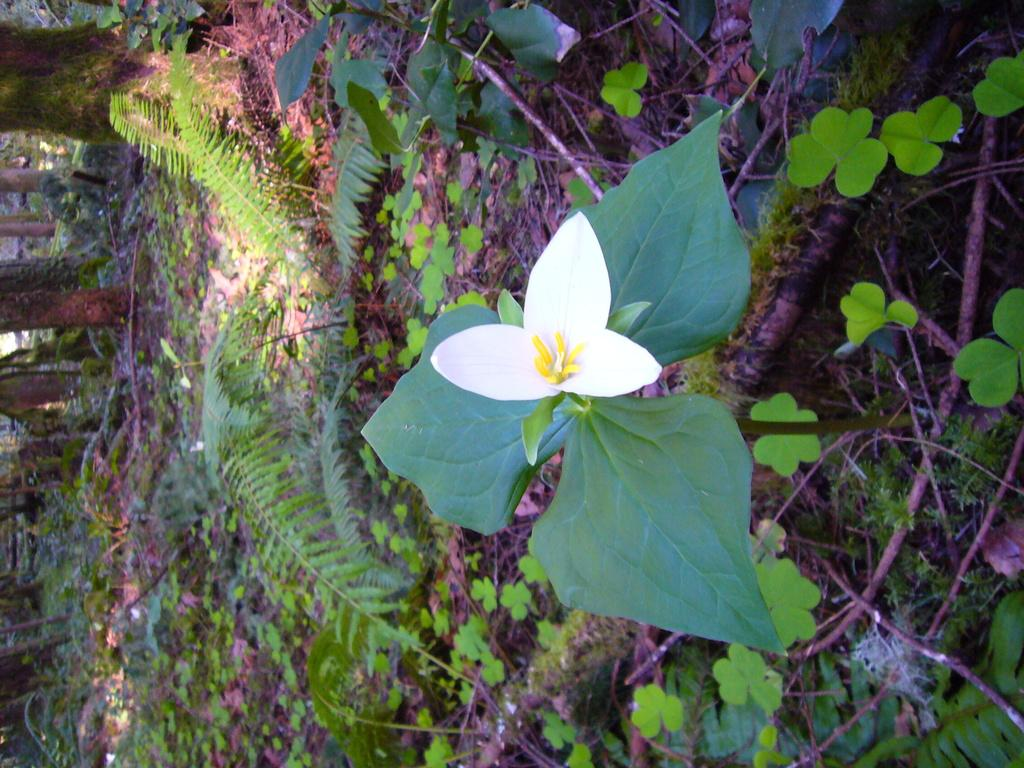What type of flower is present in the image? There is a white color flower in the image. What color are the leaves surrounding the flower? There are dew green color leaves in the image. What can be seen in the background of the image? There are trees visible in the background of the image. What type of marble is used to decorate the flower in the image? There is no marble present in the image; it features a white flower with green leaves and trees in the background. What kind of food is being served on the leaves of the flower in the image? There is no food present in the image; it only features a white flower, green leaves, and trees in the background. 